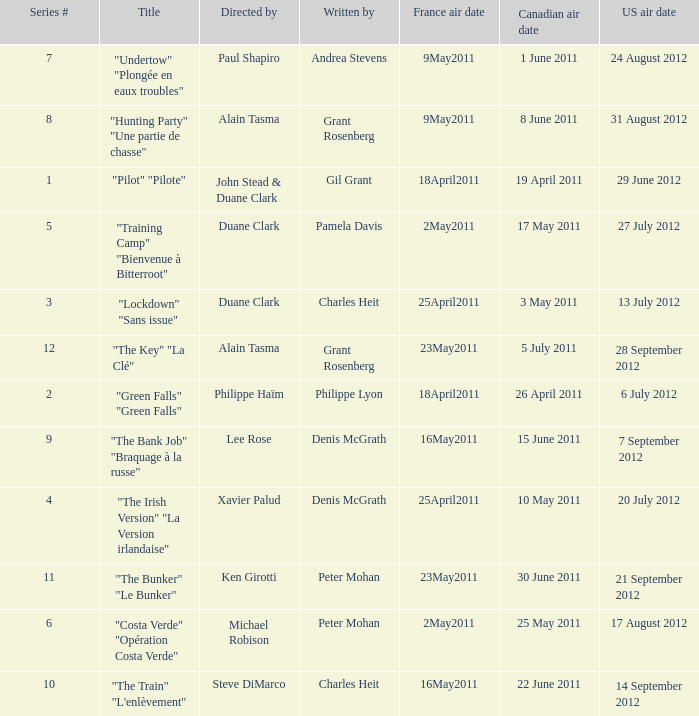What is the series # when the US air date is 20 July 2012? 4.0. 